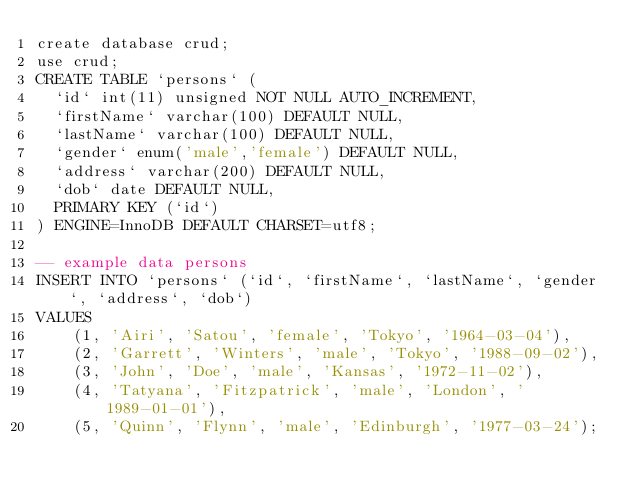<code> <loc_0><loc_0><loc_500><loc_500><_SQL_>create database crud;
use crud;
CREATE TABLE `persons` (
  `id` int(11) unsigned NOT NULL AUTO_INCREMENT,
  `firstName` varchar(100) DEFAULT NULL,
  `lastName` varchar(100) DEFAULT NULL,
  `gender` enum('male','female') DEFAULT NULL,
  `address` varchar(200) DEFAULT NULL,
  `dob` date DEFAULT NULL,
  PRIMARY KEY (`id`)
) ENGINE=InnoDB DEFAULT CHARSET=utf8;
 
-- example data persons
INSERT INTO `persons` (`id`, `firstName`, `lastName`, `gender`, `address`, `dob`)
VALUES
    (1, 'Airi', 'Satou', 'female', 'Tokyo', '1964-03-04'),
    (2, 'Garrett', 'Winters', 'male', 'Tokyo', '1988-09-02'),
    (3, 'John', 'Doe', 'male', 'Kansas', '1972-11-02'),
    (4, 'Tatyana', 'Fitzpatrick', 'male', 'London', '1989-01-01'),
    (5, 'Quinn', 'Flynn', 'male', 'Edinburgh', '1977-03-24');</code> 